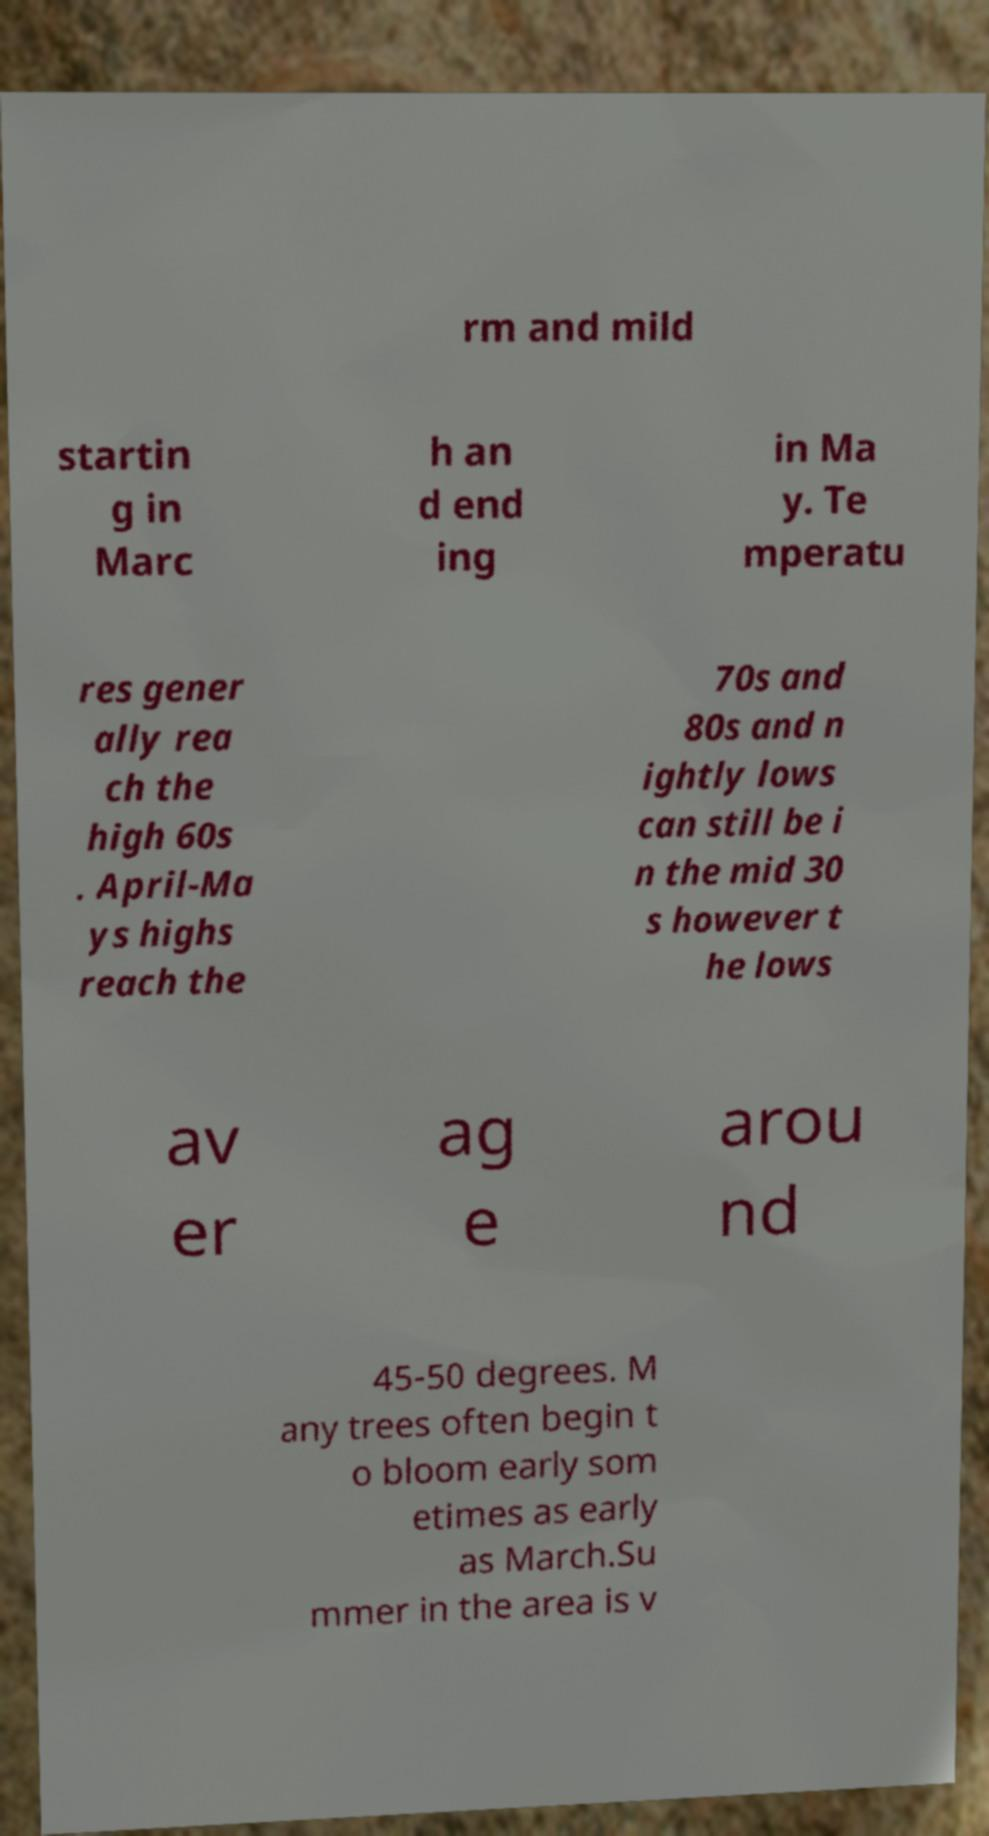Could you extract and type out the text from this image? rm and mild startin g in Marc h an d end ing in Ma y. Te mperatu res gener ally rea ch the high 60s . April-Ma ys highs reach the 70s and 80s and n ightly lows can still be i n the mid 30 s however t he lows av er ag e arou nd 45-50 degrees. M any trees often begin t o bloom early som etimes as early as March.Su mmer in the area is v 